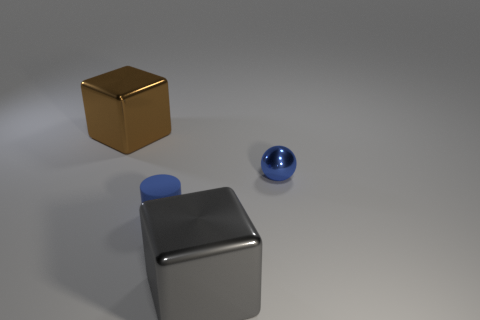Is there anything else that has the same material as the blue cylinder?
Provide a short and direct response. No. There is a large cube that is behind the tiny blue thing to the right of the gray metal cube that is in front of the tiny blue shiny ball; what is its color?
Your answer should be very brief. Brown. What number of objects are either large metallic blocks behind the metallic ball or gray objects?
Your response must be concise. 2. What is the material of the other object that is the same size as the rubber thing?
Make the answer very short. Metal. What material is the thing right of the large object that is in front of the thing that is right of the big gray thing?
Provide a succinct answer. Metal. The tiny rubber cylinder has what color?
Ensure brevity in your answer.  Blue. How many tiny objects are gray rubber balls or gray metallic objects?
Make the answer very short. 0. There is another small object that is the same color as the tiny metallic object; what is its material?
Provide a short and direct response. Rubber. Is the material of the blue thing on the right side of the gray metal block the same as the big object that is right of the brown metal object?
Provide a succinct answer. Yes. Is there a yellow metallic thing?
Keep it short and to the point. No. 